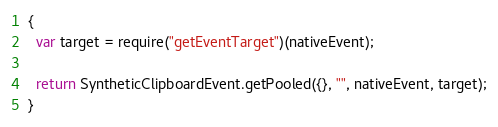<code> <loc_0><loc_0><loc_500><loc_500><_JavaScript_>{
  var target = require("getEventTarget")(nativeEvent);

  return SyntheticClipboardEvent.getPooled({}, "", nativeEvent, target);
}
</code> 